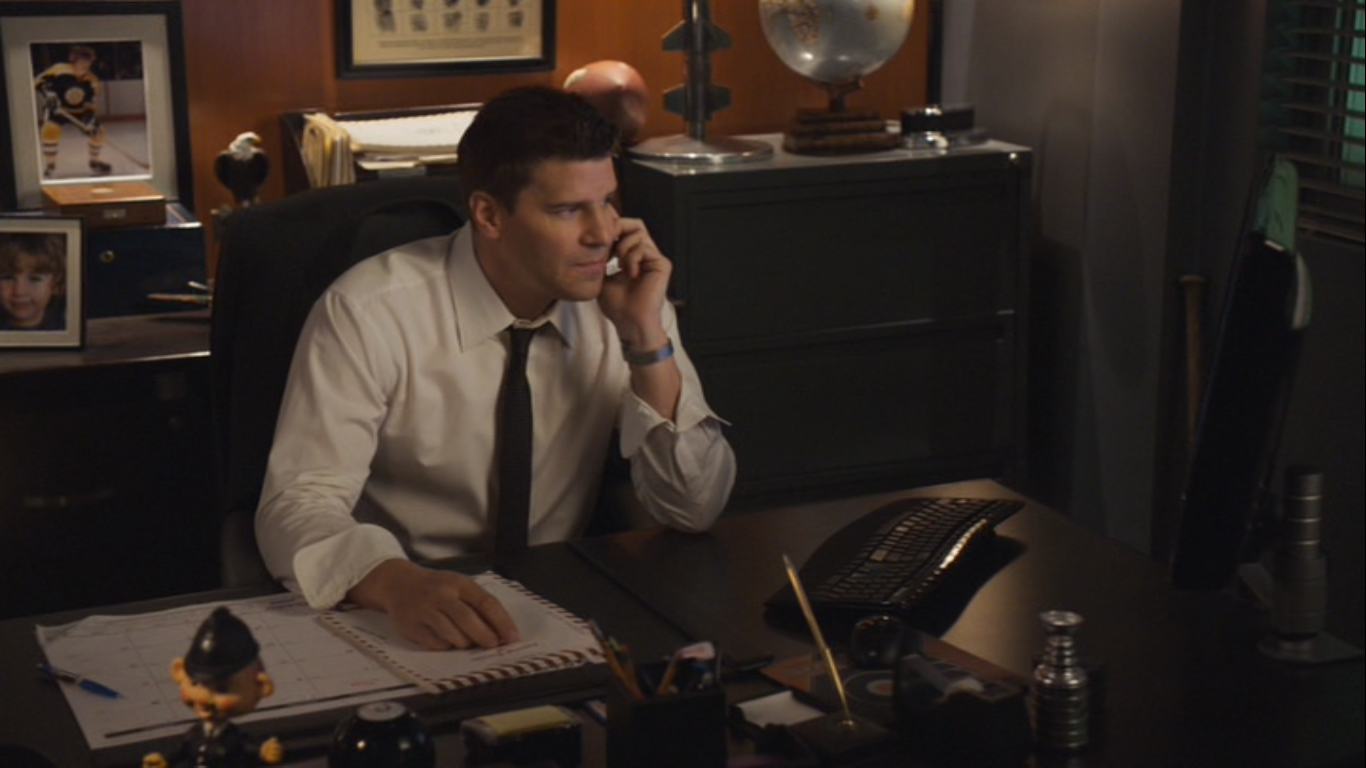Can you describe the various objects on the desk and their possible significance? On the desk, there are several noteworthy items. First, there's a keyboard, indicating that the character's work involves the use of a computer, probably for research or communication. Next, there's a notepad under the character's hand, which suggests that he might be jotting down important notes from the phone call. Additionally, there is a small, distinctive trophy which could represent an achievement or accolade in his professional life. We also see a ballpoint pen, reinforcing the theme of note-taking and documentation. There is also a small figurine of a police officer, which might be a motivational figure or a reminder of his duties. Lastly, there's a framed photo of a child, likely indicating a personal connection or motivation driving the character's diligence in his work. What kind of emotions are being conveyed by the character in the image? The character in the image conveys a sense of concentration and seriousness. His focused gaze and posture while holding the phone indicate that he is deeply engaged in the conversation. The intensity in his expression suggests that the call is important and possibly involves critical information. The overall ambiance of the office, with its dark tones and orderly layout, further accentuates a mood of professionalism and commitment to his work. This character appears dedicated, organized, and deeply involved in a significant aspect of his job. 